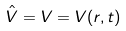Convert formula to latex. <formula><loc_0><loc_0><loc_500><loc_500>\hat { V } = V = V ( r , t )</formula> 